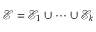Convert formula to latex. <formula><loc_0><loc_0><loc_500><loc_500>\mathcal { E } = \mathcal { E } _ { 1 } \cup \dots \cup \mathcal { E } _ { k }</formula> 